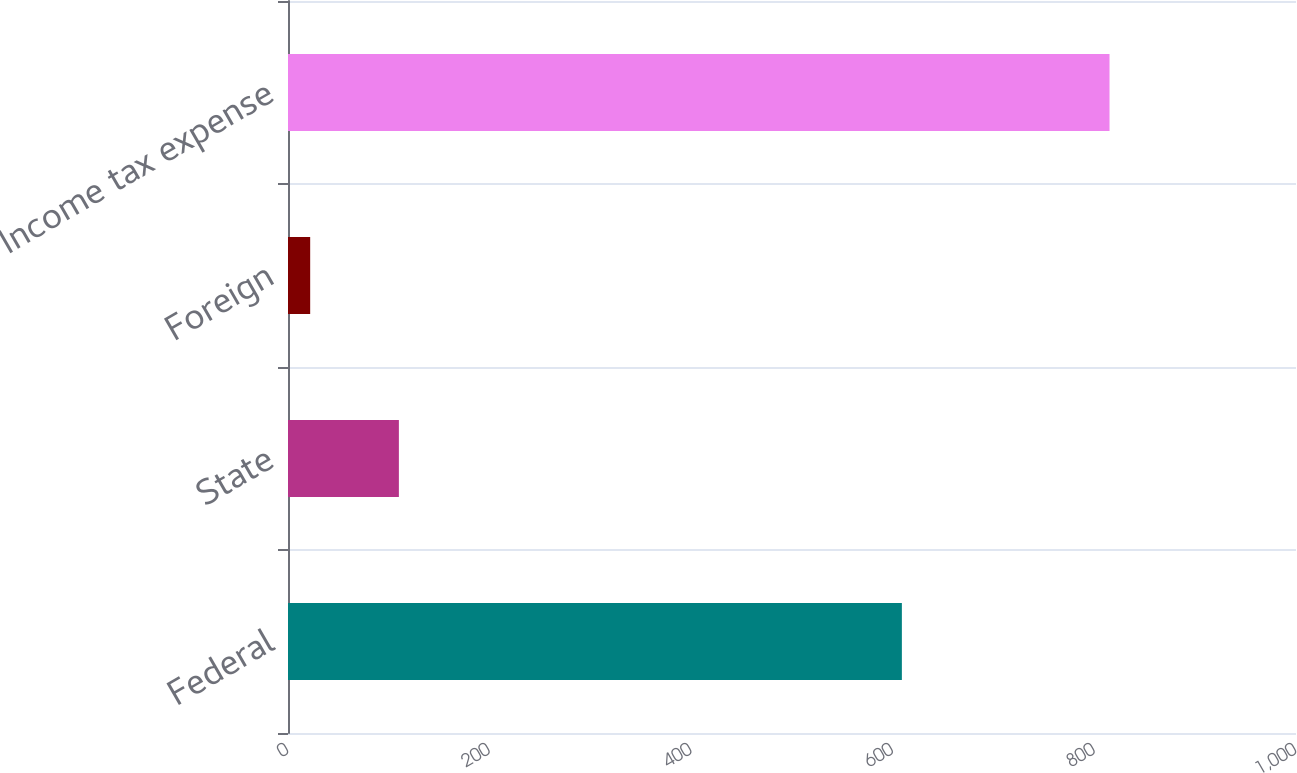<chart> <loc_0><loc_0><loc_500><loc_500><bar_chart><fcel>Federal<fcel>State<fcel>Foreign<fcel>Income tax expense<nl><fcel>609<fcel>110<fcel>22<fcel>815<nl></chart> 